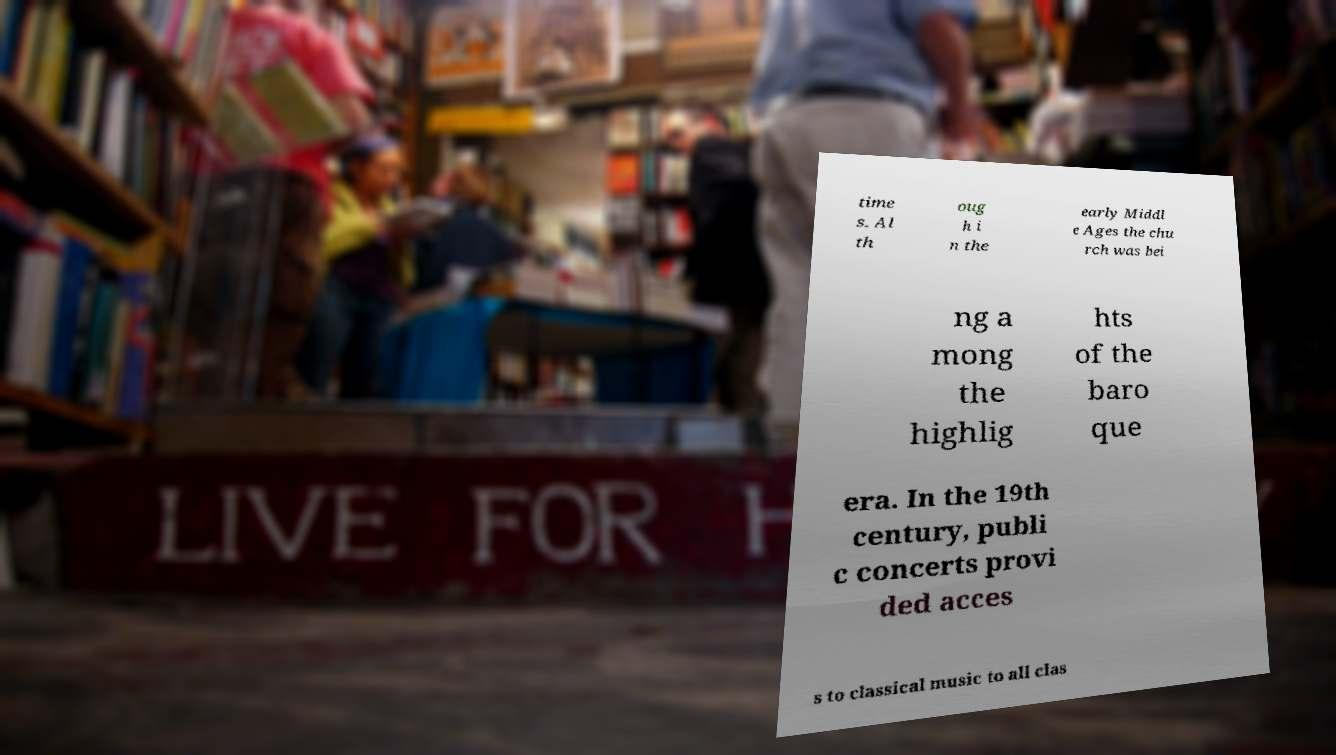I need the written content from this picture converted into text. Can you do that? time s. Al th oug h i n the early Middl e Ages the chu rch was bei ng a mong the highlig hts of the baro que era. In the 19th century, publi c concerts provi ded acces s to classical music to all clas 